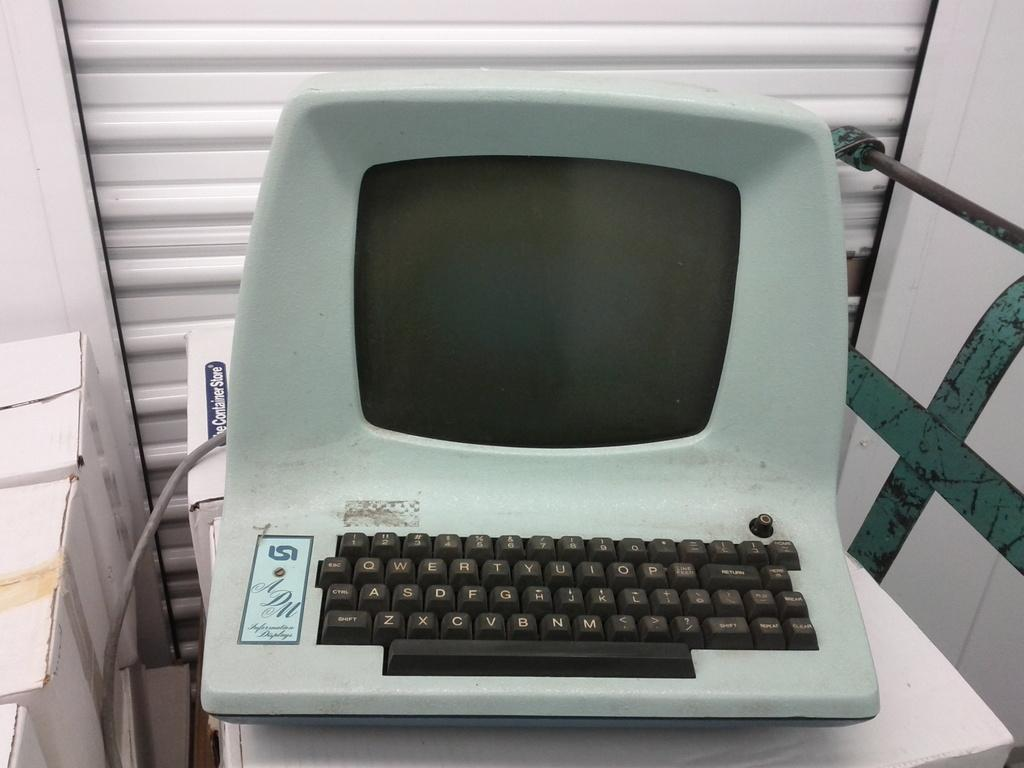<image>
Relay a brief, clear account of the picture shown. An old computer sitting on a box from the Container Store. 